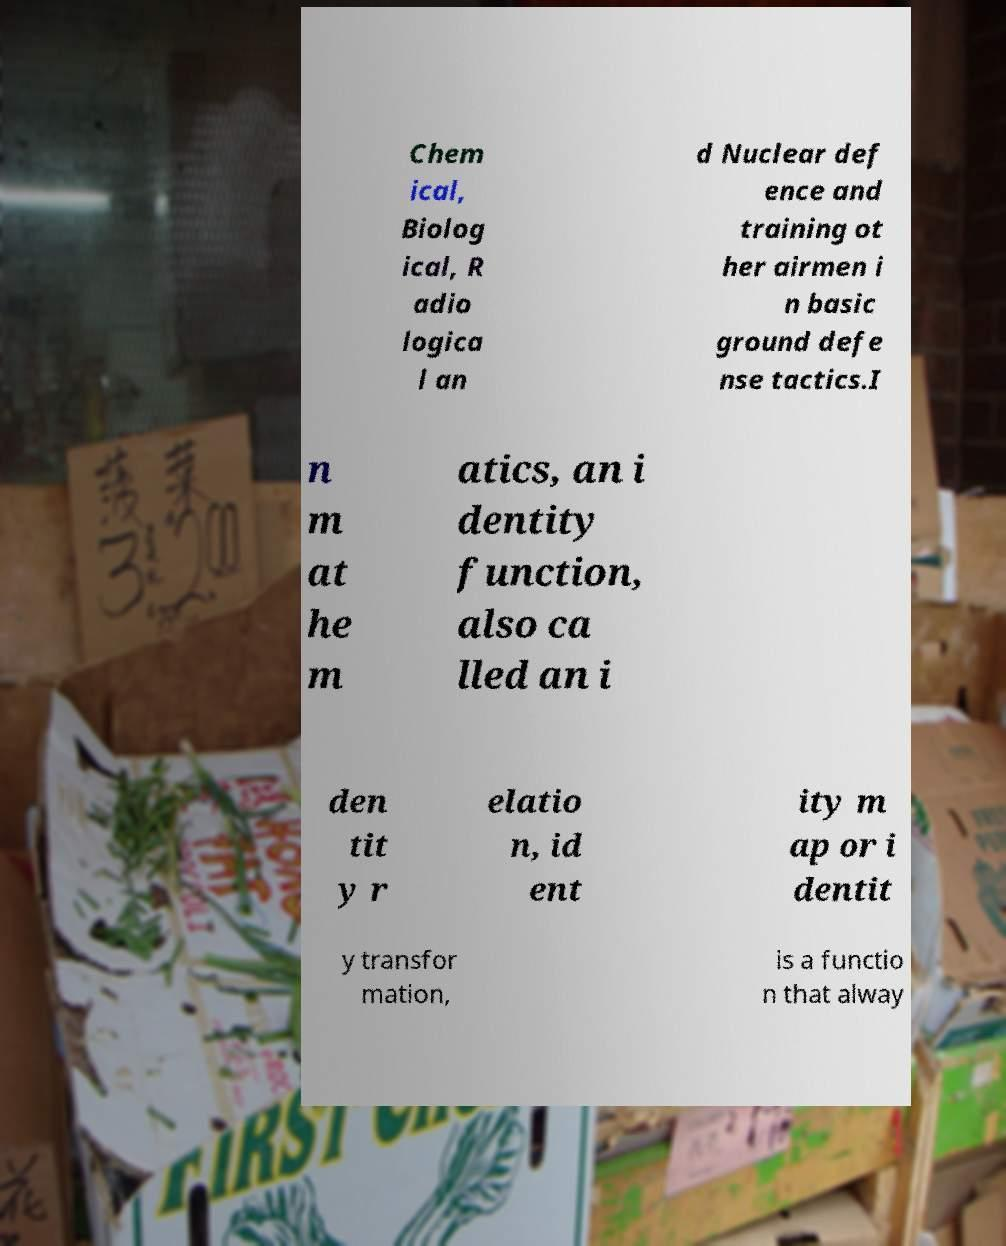Please read and relay the text visible in this image. What does it say? Chem ical, Biolog ical, R adio logica l an d Nuclear def ence and training ot her airmen i n basic ground defe nse tactics.I n m at he m atics, an i dentity function, also ca lled an i den tit y r elatio n, id ent ity m ap or i dentit y transfor mation, is a functio n that alway 